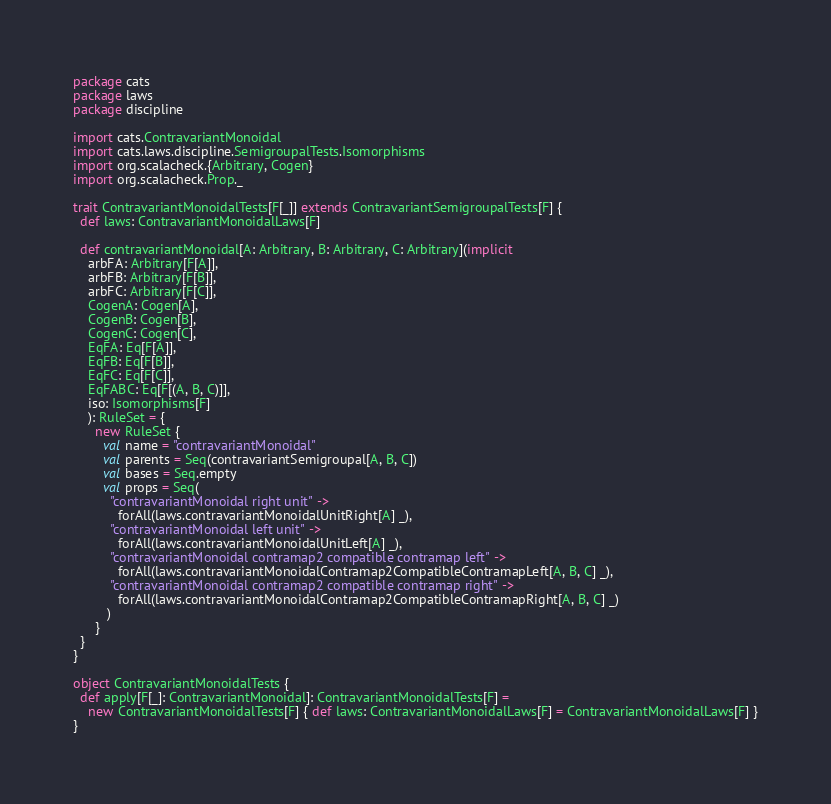Convert code to text. <code><loc_0><loc_0><loc_500><loc_500><_Scala_>package cats
package laws
package discipline

import cats.ContravariantMonoidal
import cats.laws.discipline.SemigroupalTests.Isomorphisms
import org.scalacheck.{Arbitrary, Cogen}
import org.scalacheck.Prop._

trait ContravariantMonoidalTests[F[_]] extends ContravariantSemigroupalTests[F] {
  def laws: ContravariantMonoidalLaws[F]

  def contravariantMonoidal[A: Arbitrary, B: Arbitrary, C: Arbitrary](implicit
    arbFA: Arbitrary[F[A]],
    arbFB: Arbitrary[F[B]],
    arbFC: Arbitrary[F[C]],
    CogenA: Cogen[A],
    CogenB: Cogen[B],
    CogenC: Cogen[C],
    EqFA: Eq[F[A]],
    EqFB: Eq[F[B]],
    EqFC: Eq[F[C]],
    EqFABC: Eq[F[(A, B, C)]],
    iso: Isomorphisms[F]
    ): RuleSet = {
      new RuleSet {
        val name = "contravariantMonoidal"
        val parents = Seq(contravariantSemigroupal[A, B, C])
        val bases = Seq.empty
        val props = Seq(
          "contravariantMonoidal right unit" ->
            forAll(laws.contravariantMonoidalUnitRight[A] _),
          "contravariantMonoidal left unit" ->
            forAll(laws.contravariantMonoidalUnitLeft[A] _),
          "contravariantMonoidal contramap2 compatible contramap left" ->
            forAll(laws.contravariantMonoidalContramap2CompatibleContramapLeft[A, B, C] _),
          "contravariantMonoidal contramap2 compatible contramap right" ->
            forAll(laws.contravariantMonoidalContramap2CompatibleContramapRight[A, B, C] _)
         )
      }
  }
}

object ContravariantMonoidalTests {
  def apply[F[_]: ContravariantMonoidal]: ContravariantMonoidalTests[F] =
    new ContravariantMonoidalTests[F] { def laws: ContravariantMonoidalLaws[F] = ContravariantMonoidalLaws[F] }
}
</code> 